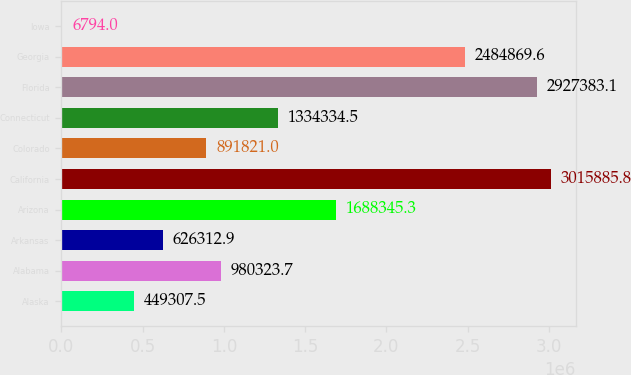Convert chart. <chart><loc_0><loc_0><loc_500><loc_500><bar_chart><fcel>Alaska<fcel>Alabama<fcel>Arkansas<fcel>Arizona<fcel>California<fcel>Colorado<fcel>Connecticut<fcel>Florida<fcel>Georgia<fcel>Iowa<nl><fcel>449308<fcel>980324<fcel>626313<fcel>1.68835e+06<fcel>3.01589e+06<fcel>891821<fcel>1.33433e+06<fcel>2.92738e+06<fcel>2.48487e+06<fcel>6794<nl></chart> 